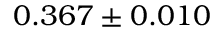Convert formula to latex. <formula><loc_0><loc_0><loc_500><loc_500>0 . 3 6 7 \pm 0 . 0 1 0</formula> 